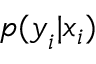<formula> <loc_0><loc_0><loc_500><loc_500>p ( y _ { i } | x _ { i } )</formula> 